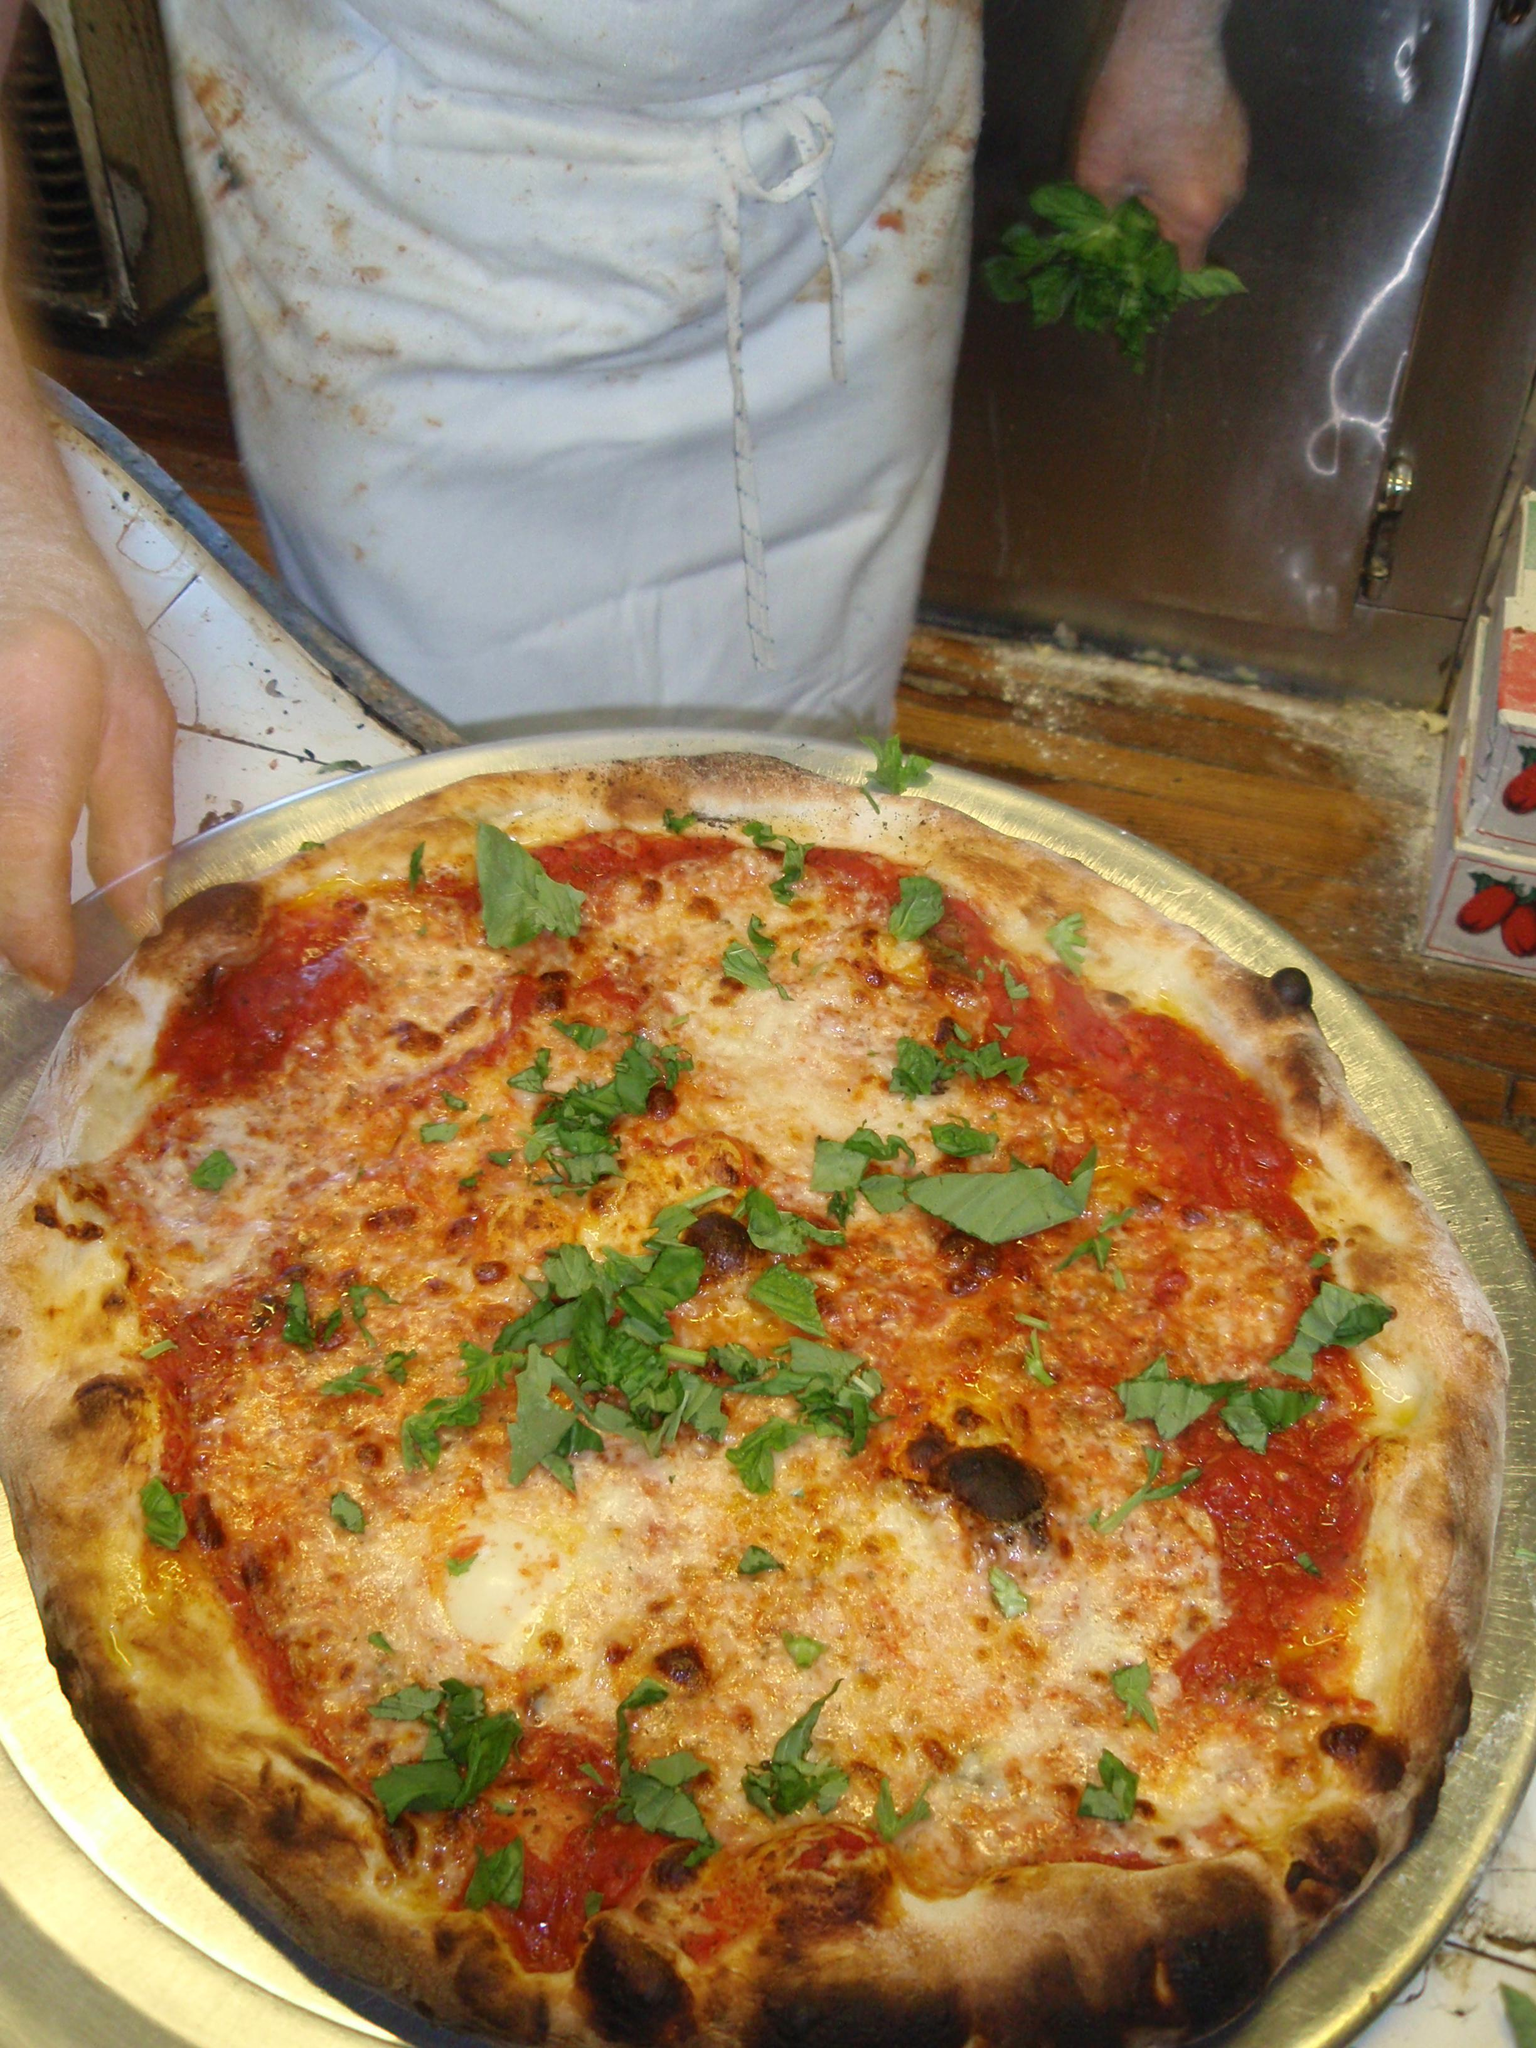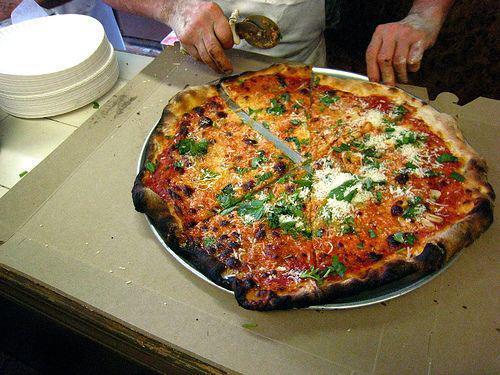The first image is the image on the left, the second image is the image on the right. Given the left and right images, does the statement "A person is holding a round-bladed cutting tool over a round pizza in the right image." hold true? Answer yes or no. Yes. The first image is the image on the left, the second image is the image on the right. For the images displayed, is the sentence "In at least one of the images, there's a single pizza on a metal pan." factually correct? Answer yes or no. Yes. 